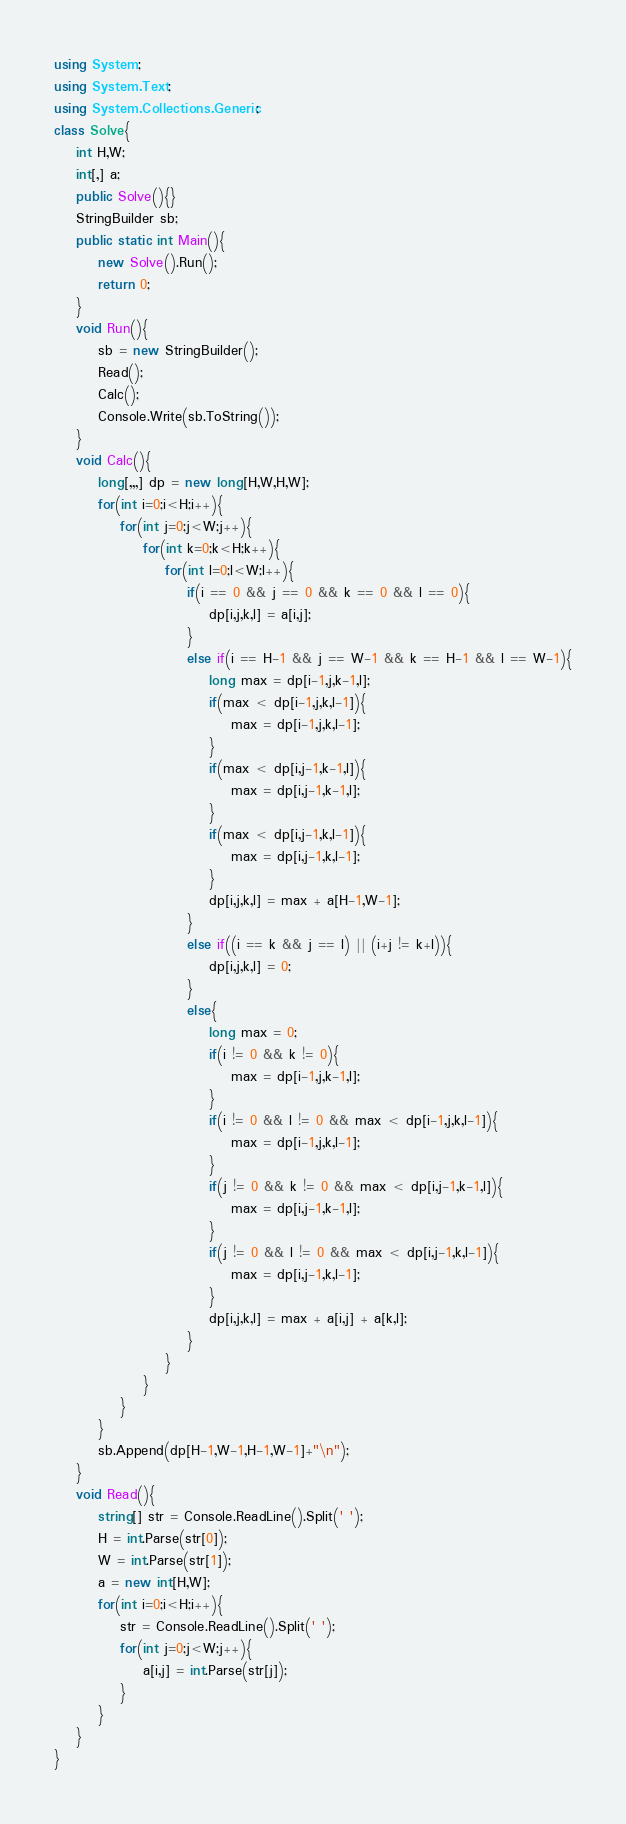<code> <loc_0><loc_0><loc_500><loc_500><_C#_>using System;
using System.Text;
using System.Collections.Generic;
class Solve{
    int H,W;
    int[,] a; 
    public Solve(){}
    StringBuilder sb;
    public static int Main(){
        new Solve().Run();
        return 0;
    }
    void Run(){
        sb = new StringBuilder();
        Read();
        Calc();
        Console.Write(sb.ToString());
    }
    void Calc(){
        long[,,,] dp = new long[H,W,H,W];
        for(int i=0;i<H;i++){
            for(int j=0;j<W;j++){
                for(int k=0;k<H;k++){
                    for(int l=0;l<W;l++){
                        if(i == 0 && j == 0 && k == 0 && l == 0){
                            dp[i,j,k,l] = a[i,j];
                        }
                        else if(i == H-1 && j == W-1 && k == H-1 && l == W-1){
                            long max = dp[i-1,j,k-1,l];
                            if(max < dp[i-1,j,k,l-1]){
                                max = dp[i-1,j,k,l-1];
                            }
                            if(max < dp[i,j-1,k-1,l]){
                                max = dp[i,j-1,k-1,l];
                            }
                            if(max < dp[i,j-1,k,l-1]){
                                max = dp[i,j-1,k,l-1];
                            }
                            dp[i,j,k,l] = max + a[H-1,W-1];
                        }
                        else if((i == k && j == l) || (i+j != k+l)){
                            dp[i,j,k,l] = 0;
                        }
                        else{
                            long max = 0;
                            if(i != 0 && k != 0){
                                max = dp[i-1,j,k-1,l];
                            }
                            if(i != 0 && l != 0 && max < dp[i-1,j,k,l-1]){
                                max = dp[i-1,j,k,l-1];
                            }
                            if(j != 0 && k != 0 && max < dp[i,j-1,k-1,l]){
                                max = dp[i,j-1,k-1,l];
                            }
                            if(j != 0 && l != 0 && max < dp[i,j-1,k,l-1]){
                                max = dp[i,j-1,k,l-1];
                            }
                            dp[i,j,k,l] = max + a[i,j] + a[k,l];
                        }
                    }
                }
            }
        }
        sb.Append(dp[H-1,W-1,H-1,W-1]+"\n");
    }
    void Read(){
        string[] str = Console.ReadLine().Split(' ');
        H = int.Parse(str[0]);
        W = int.Parse(str[1]);
        a = new int[H,W];
        for(int i=0;i<H;i++){
            str = Console.ReadLine().Split(' ');
            for(int j=0;j<W;j++){
                a[i,j] = int.Parse(str[j]);
            }
        }
    }    
}</code> 